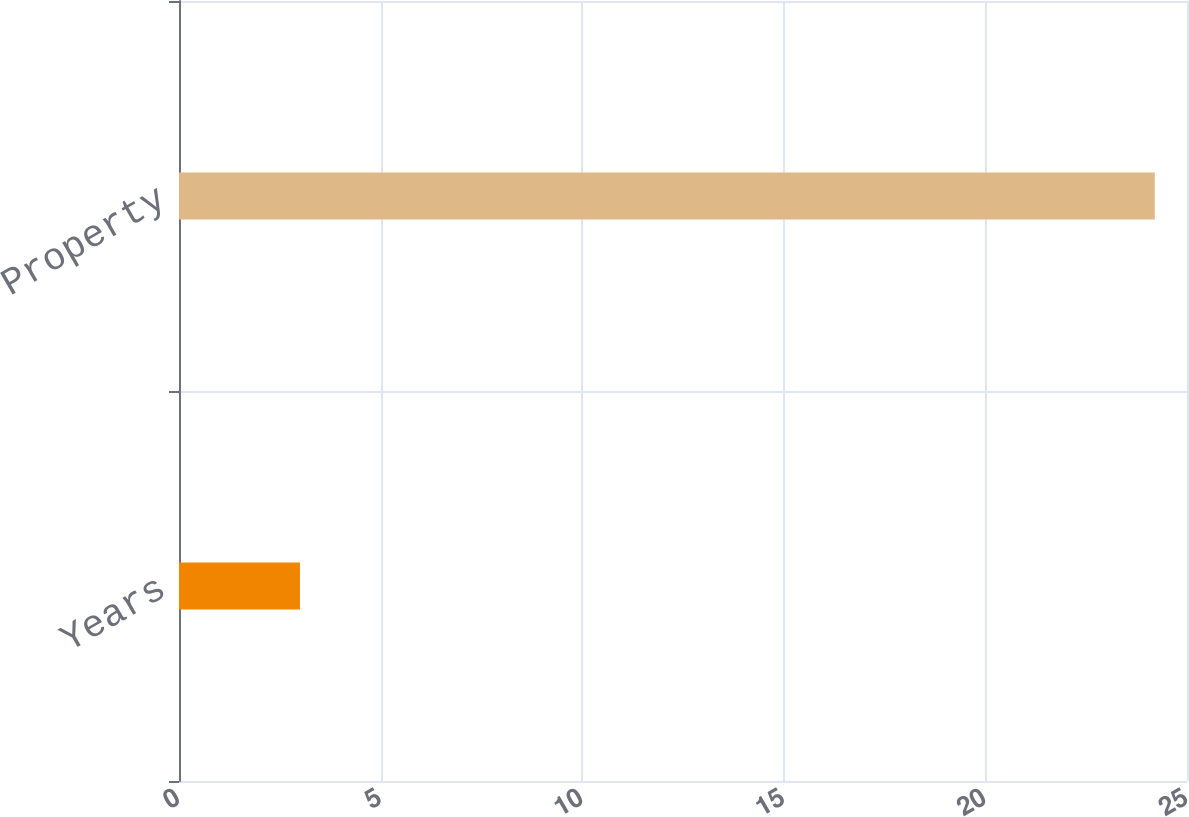Convert chart. <chart><loc_0><loc_0><loc_500><loc_500><bar_chart><fcel>Years<fcel>Property<nl><fcel>3<fcel>24.2<nl></chart> 